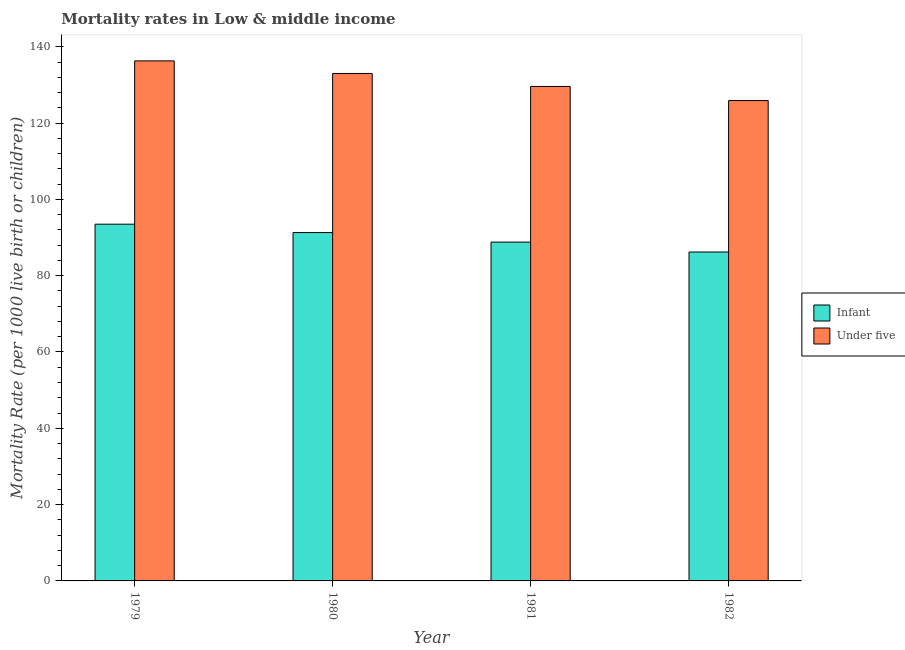How many different coloured bars are there?
Your answer should be very brief. 2. How many groups of bars are there?
Provide a short and direct response. 4. Are the number of bars per tick equal to the number of legend labels?
Provide a succinct answer. Yes. Are the number of bars on each tick of the X-axis equal?
Ensure brevity in your answer.  Yes. What is the label of the 1st group of bars from the left?
Keep it short and to the point. 1979. What is the infant mortality rate in 1980?
Ensure brevity in your answer.  91.3. Across all years, what is the maximum under-5 mortality rate?
Offer a very short reply. 136.3. Across all years, what is the minimum infant mortality rate?
Give a very brief answer. 86.2. In which year was the under-5 mortality rate maximum?
Provide a short and direct response. 1979. In which year was the under-5 mortality rate minimum?
Keep it short and to the point. 1982. What is the total under-5 mortality rate in the graph?
Provide a succinct answer. 524.8. What is the difference between the under-5 mortality rate in 1980 and that in 1981?
Your response must be concise. 3.4. What is the difference between the under-5 mortality rate in 1981 and the infant mortality rate in 1980?
Your answer should be compact. -3.4. What is the average infant mortality rate per year?
Provide a short and direct response. 89.95. In the year 1979, what is the difference between the under-5 mortality rate and infant mortality rate?
Offer a very short reply. 0. What is the ratio of the infant mortality rate in 1981 to that in 1982?
Keep it short and to the point. 1.03. What is the difference between the highest and the second highest infant mortality rate?
Offer a terse response. 2.2. What is the difference between the highest and the lowest under-5 mortality rate?
Offer a terse response. 10.4. In how many years, is the under-5 mortality rate greater than the average under-5 mortality rate taken over all years?
Keep it short and to the point. 2. Is the sum of the under-5 mortality rate in 1979 and 1982 greater than the maximum infant mortality rate across all years?
Ensure brevity in your answer.  Yes. What does the 2nd bar from the left in 1979 represents?
Your answer should be compact. Under five. What does the 1st bar from the right in 1982 represents?
Your response must be concise. Under five. How many bars are there?
Your answer should be compact. 8. Are all the bars in the graph horizontal?
Make the answer very short. No. What is the difference between two consecutive major ticks on the Y-axis?
Provide a short and direct response. 20. Does the graph contain grids?
Your answer should be very brief. No. How many legend labels are there?
Give a very brief answer. 2. What is the title of the graph?
Make the answer very short. Mortality rates in Low & middle income. Does "Secondary school" appear as one of the legend labels in the graph?
Your response must be concise. No. What is the label or title of the Y-axis?
Ensure brevity in your answer.  Mortality Rate (per 1000 live birth or children). What is the Mortality Rate (per 1000 live birth or children) of Infant in 1979?
Offer a very short reply. 93.5. What is the Mortality Rate (per 1000 live birth or children) in Under five in 1979?
Offer a terse response. 136.3. What is the Mortality Rate (per 1000 live birth or children) of Infant in 1980?
Make the answer very short. 91.3. What is the Mortality Rate (per 1000 live birth or children) of Under five in 1980?
Keep it short and to the point. 133. What is the Mortality Rate (per 1000 live birth or children) in Infant in 1981?
Offer a very short reply. 88.8. What is the Mortality Rate (per 1000 live birth or children) of Under five in 1981?
Offer a terse response. 129.6. What is the Mortality Rate (per 1000 live birth or children) of Infant in 1982?
Offer a terse response. 86.2. What is the Mortality Rate (per 1000 live birth or children) in Under five in 1982?
Offer a terse response. 125.9. Across all years, what is the maximum Mortality Rate (per 1000 live birth or children) of Infant?
Provide a succinct answer. 93.5. Across all years, what is the maximum Mortality Rate (per 1000 live birth or children) of Under five?
Keep it short and to the point. 136.3. Across all years, what is the minimum Mortality Rate (per 1000 live birth or children) in Infant?
Your response must be concise. 86.2. Across all years, what is the minimum Mortality Rate (per 1000 live birth or children) of Under five?
Keep it short and to the point. 125.9. What is the total Mortality Rate (per 1000 live birth or children) in Infant in the graph?
Give a very brief answer. 359.8. What is the total Mortality Rate (per 1000 live birth or children) of Under five in the graph?
Your response must be concise. 524.8. What is the difference between the Mortality Rate (per 1000 live birth or children) in Infant in 1979 and that in 1980?
Give a very brief answer. 2.2. What is the difference between the Mortality Rate (per 1000 live birth or children) of Under five in 1979 and that in 1980?
Give a very brief answer. 3.3. What is the difference between the Mortality Rate (per 1000 live birth or children) of Under five in 1979 and that in 1982?
Your answer should be very brief. 10.4. What is the difference between the Mortality Rate (per 1000 live birth or children) in Under five in 1980 and that in 1981?
Give a very brief answer. 3.4. What is the difference between the Mortality Rate (per 1000 live birth or children) of Infant in 1981 and that in 1982?
Provide a succinct answer. 2.6. What is the difference between the Mortality Rate (per 1000 live birth or children) of Infant in 1979 and the Mortality Rate (per 1000 live birth or children) of Under five in 1980?
Provide a short and direct response. -39.5. What is the difference between the Mortality Rate (per 1000 live birth or children) in Infant in 1979 and the Mortality Rate (per 1000 live birth or children) in Under five in 1981?
Your answer should be compact. -36.1. What is the difference between the Mortality Rate (per 1000 live birth or children) in Infant in 1979 and the Mortality Rate (per 1000 live birth or children) in Under five in 1982?
Give a very brief answer. -32.4. What is the difference between the Mortality Rate (per 1000 live birth or children) in Infant in 1980 and the Mortality Rate (per 1000 live birth or children) in Under five in 1981?
Give a very brief answer. -38.3. What is the difference between the Mortality Rate (per 1000 live birth or children) of Infant in 1980 and the Mortality Rate (per 1000 live birth or children) of Under five in 1982?
Provide a short and direct response. -34.6. What is the difference between the Mortality Rate (per 1000 live birth or children) in Infant in 1981 and the Mortality Rate (per 1000 live birth or children) in Under five in 1982?
Ensure brevity in your answer.  -37.1. What is the average Mortality Rate (per 1000 live birth or children) in Infant per year?
Offer a very short reply. 89.95. What is the average Mortality Rate (per 1000 live birth or children) of Under five per year?
Offer a terse response. 131.2. In the year 1979, what is the difference between the Mortality Rate (per 1000 live birth or children) in Infant and Mortality Rate (per 1000 live birth or children) in Under five?
Keep it short and to the point. -42.8. In the year 1980, what is the difference between the Mortality Rate (per 1000 live birth or children) in Infant and Mortality Rate (per 1000 live birth or children) in Under five?
Offer a very short reply. -41.7. In the year 1981, what is the difference between the Mortality Rate (per 1000 live birth or children) in Infant and Mortality Rate (per 1000 live birth or children) in Under five?
Provide a succinct answer. -40.8. In the year 1982, what is the difference between the Mortality Rate (per 1000 live birth or children) of Infant and Mortality Rate (per 1000 live birth or children) of Under five?
Offer a terse response. -39.7. What is the ratio of the Mortality Rate (per 1000 live birth or children) in Infant in 1979 to that in 1980?
Keep it short and to the point. 1.02. What is the ratio of the Mortality Rate (per 1000 live birth or children) of Under five in 1979 to that in 1980?
Provide a short and direct response. 1.02. What is the ratio of the Mortality Rate (per 1000 live birth or children) of Infant in 1979 to that in 1981?
Ensure brevity in your answer.  1.05. What is the ratio of the Mortality Rate (per 1000 live birth or children) of Under five in 1979 to that in 1981?
Your response must be concise. 1.05. What is the ratio of the Mortality Rate (per 1000 live birth or children) in Infant in 1979 to that in 1982?
Provide a short and direct response. 1.08. What is the ratio of the Mortality Rate (per 1000 live birth or children) of Under five in 1979 to that in 1982?
Your answer should be very brief. 1.08. What is the ratio of the Mortality Rate (per 1000 live birth or children) in Infant in 1980 to that in 1981?
Offer a terse response. 1.03. What is the ratio of the Mortality Rate (per 1000 live birth or children) of Under five in 1980 to that in 1981?
Offer a terse response. 1.03. What is the ratio of the Mortality Rate (per 1000 live birth or children) of Infant in 1980 to that in 1982?
Make the answer very short. 1.06. What is the ratio of the Mortality Rate (per 1000 live birth or children) in Under five in 1980 to that in 1982?
Your response must be concise. 1.06. What is the ratio of the Mortality Rate (per 1000 live birth or children) of Infant in 1981 to that in 1982?
Your answer should be compact. 1.03. What is the ratio of the Mortality Rate (per 1000 live birth or children) of Under five in 1981 to that in 1982?
Ensure brevity in your answer.  1.03. What is the difference between the highest and the second highest Mortality Rate (per 1000 live birth or children) in Infant?
Ensure brevity in your answer.  2.2. What is the difference between the highest and the second highest Mortality Rate (per 1000 live birth or children) in Under five?
Make the answer very short. 3.3. What is the difference between the highest and the lowest Mortality Rate (per 1000 live birth or children) in Infant?
Ensure brevity in your answer.  7.3. 